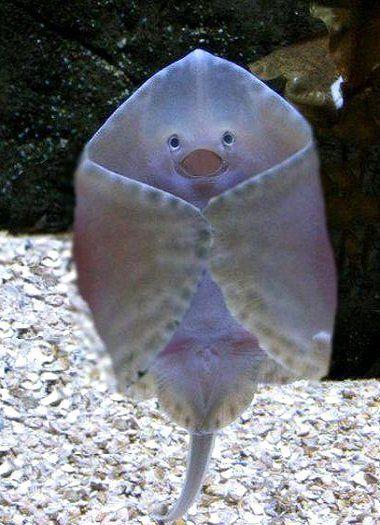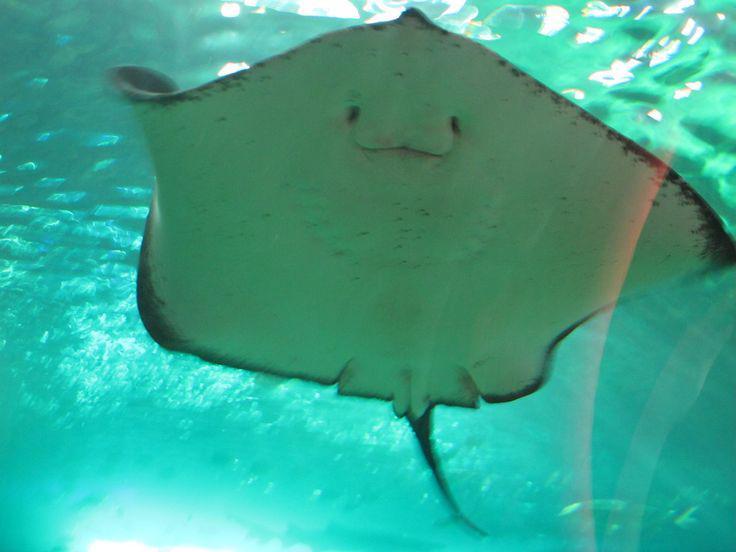The first image is the image on the left, the second image is the image on the right. For the images displayed, is the sentence "All images show an upright stingray with wings extended and underside visible." factually correct? Answer yes or no. No. The first image is the image on the left, the second image is the image on the right. Evaluate the accuracy of this statement regarding the images: "The creature appears to have its mouth slightly open in one of the images". Is it true? Answer yes or no. Yes. 